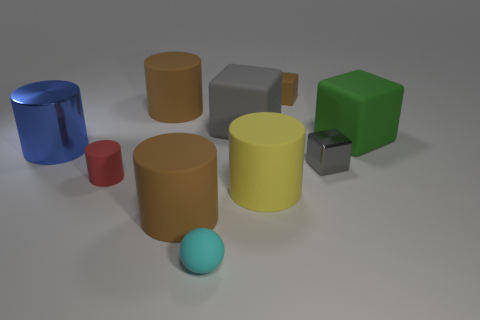Subtract all red cylinders. How many cylinders are left? 4 Subtract all brown spheres. How many brown cylinders are left? 2 Subtract all brown cubes. How many cubes are left? 3 Subtract 1 cylinders. How many cylinders are left? 4 Subtract all green cubes. Subtract all purple balls. How many cubes are left? 3 Subtract all gray cylinders. Subtract all brown matte cubes. How many objects are left? 9 Add 5 cylinders. How many cylinders are left? 10 Add 6 tiny blue cylinders. How many tiny blue cylinders exist? 6 Subtract 2 gray cubes. How many objects are left? 8 Subtract all cubes. How many objects are left? 6 